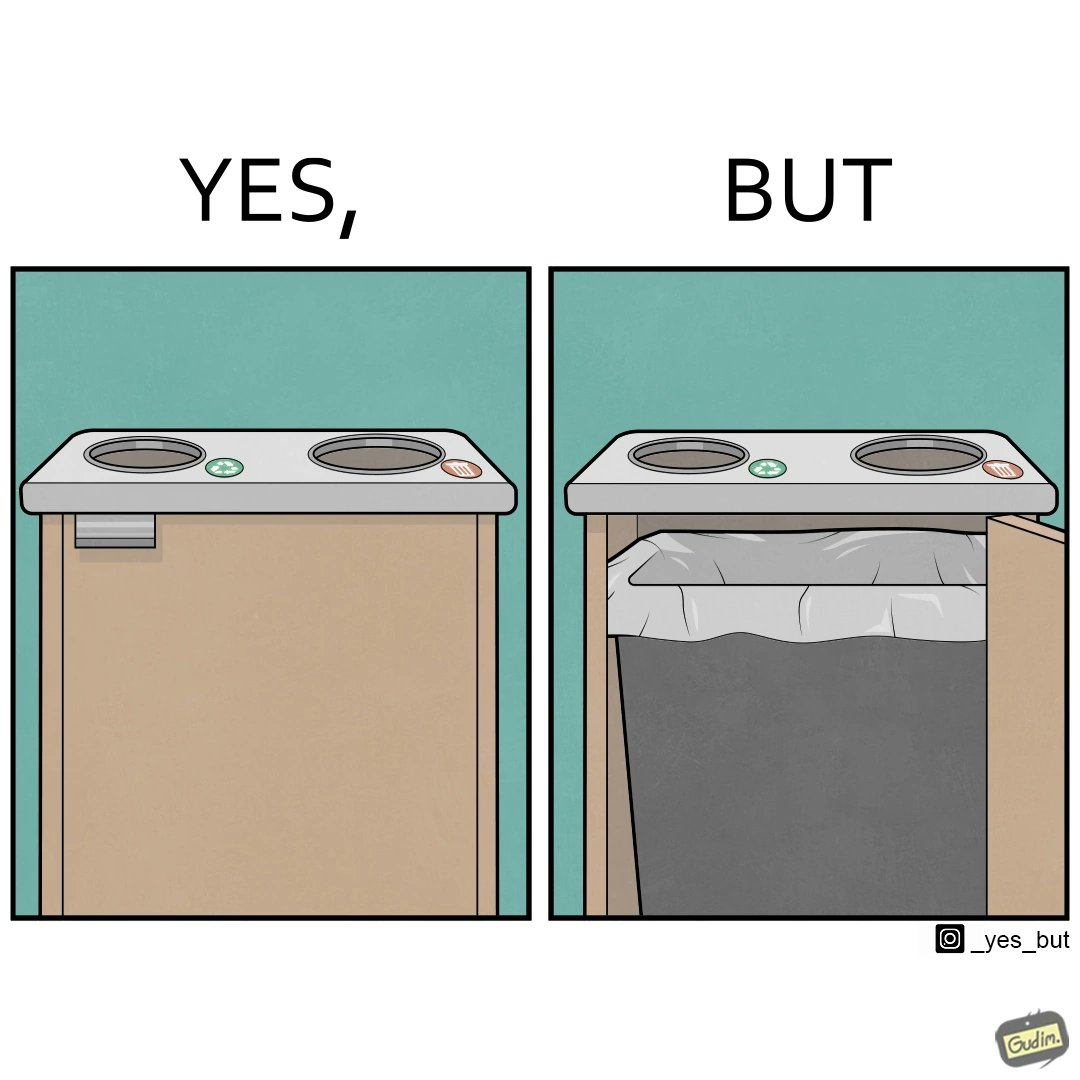What makes this image funny or satirical? The image is funny because while there are different holes provided to dump different kinds of waste, the separation is meaningless because the underlying bin which is the same. So all kinds of trash is collected together and can not be used for recycling. 